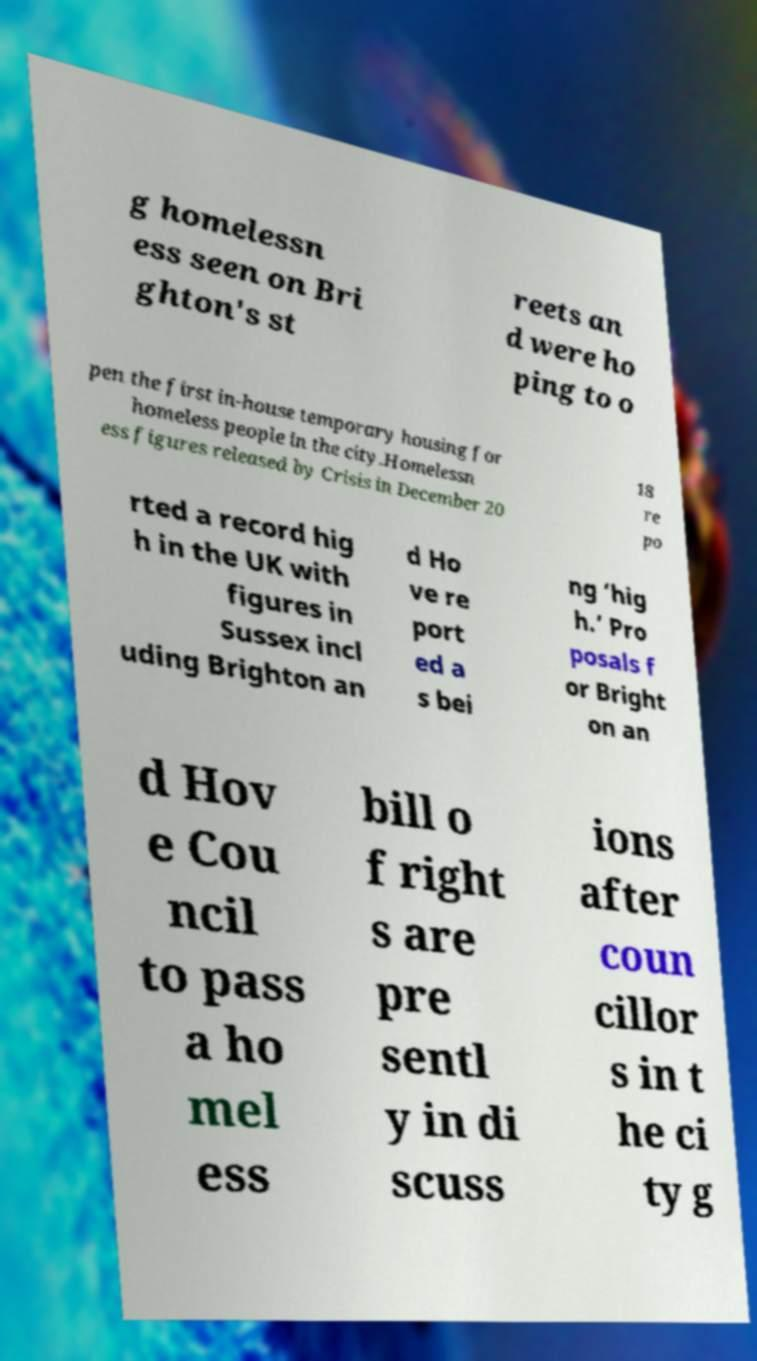Could you assist in decoding the text presented in this image and type it out clearly? g homelessn ess seen on Bri ghton's st reets an d were ho ping to o pen the first in-house temporary housing for homeless people in the city.Homelessn ess figures released by Crisis in December 20 18 re po rted a record hig h in the UK with figures in Sussex incl uding Brighton an d Ho ve re port ed a s bei ng ‘hig h.’ Pro posals f or Bright on an d Hov e Cou ncil to pass a ho mel ess bill o f right s are pre sentl y in di scuss ions after coun cillor s in t he ci ty g 